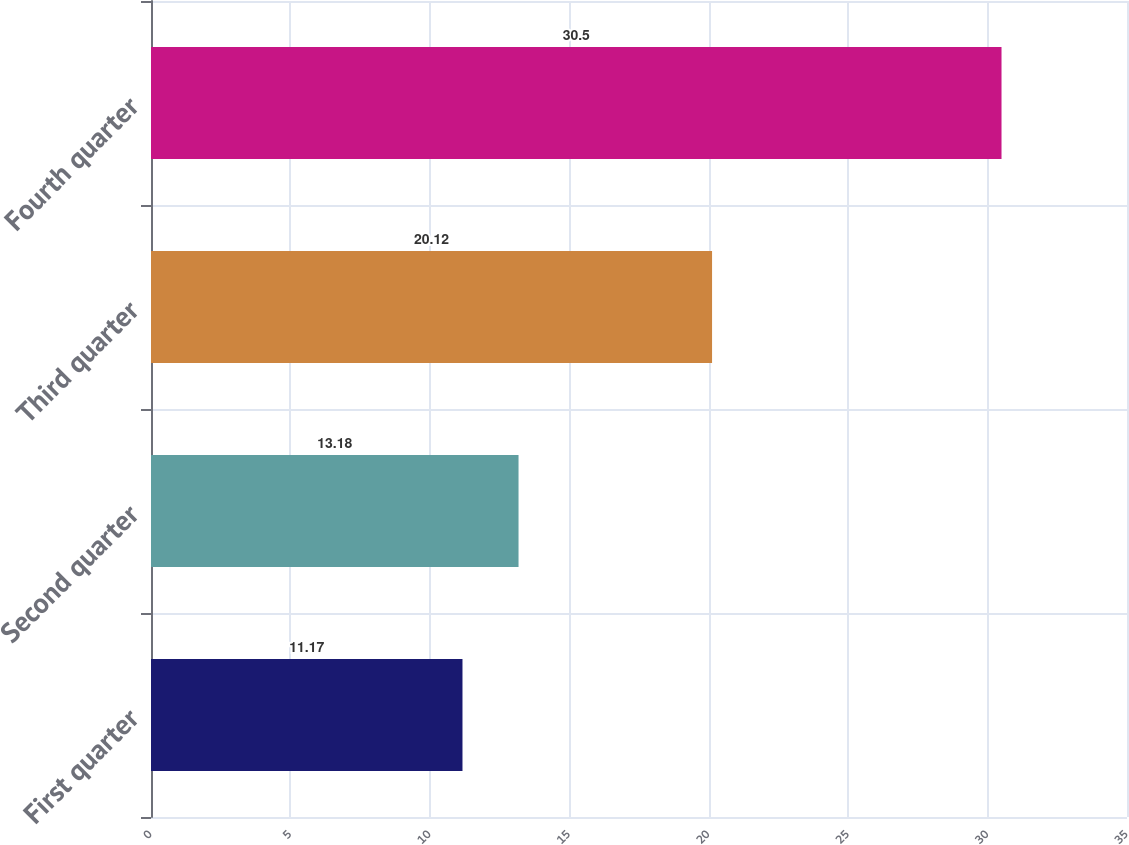Convert chart. <chart><loc_0><loc_0><loc_500><loc_500><bar_chart><fcel>First quarter<fcel>Second quarter<fcel>Third quarter<fcel>Fourth quarter<nl><fcel>11.17<fcel>13.18<fcel>20.12<fcel>30.5<nl></chart> 